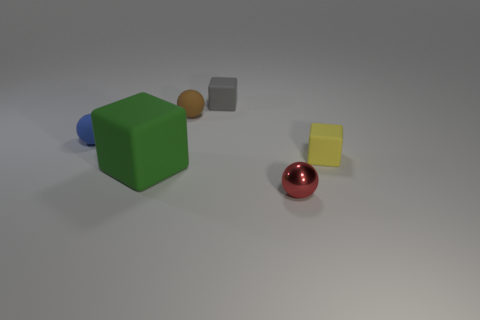Subtract all matte balls. How many balls are left? 1 Add 3 red metal balls. How many objects exist? 9 Add 6 brown objects. How many brown objects are left? 7 Add 5 big green rubber cubes. How many big green rubber cubes exist? 6 Subtract 0 green spheres. How many objects are left? 6 Subtract all green matte things. Subtract all tiny blue objects. How many objects are left? 4 